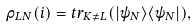<formula> <loc_0><loc_0><loc_500><loc_500>\rho _ { L N } ( i ) = t r _ { K \neq L } ( | \psi _ { N } \rangle \langle \psi _ { N } | ) ,</formula> 